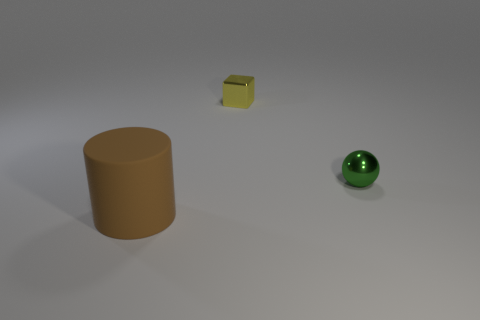What number of objects are objects to the right of the big brown matte thing or things in front of the tiny green sphere?
Keep it short and to the point. 3. Are there more spheres behind the shiny cube than green objects?
Offer a terse response. No. What number of metal things are the same size as the brown cylinder?
Offer a very short reply. 0. There is a metallic thing behind the tiny ball; does it have the same size as the matte cylinder to the left of the green metal ball?
Offer a very short reply. No. There is a object that is behind the tiny green object; how big is it?
Provide a short and direct response. Small. What size is the metallic thing that is on the left side of the tiny metal thing in front of the yellow metallic object?
Provide a succinct answer. Small. There is a block that is the same size as the green ball; what is it made of?
Make the answer very short. Metal. Are there any brown rubber cylinders on the right side of the tiny green sphere?
Provide a succinct answer. No. Is the number of large cylinders right of the large brown cylinder the same as the number of big brown cylinders?
Offer a very short reply. No. What shape is the yellow shiny thing that is the same size as the green metallic object?
Ensure brevity in your answer.  Cube. 